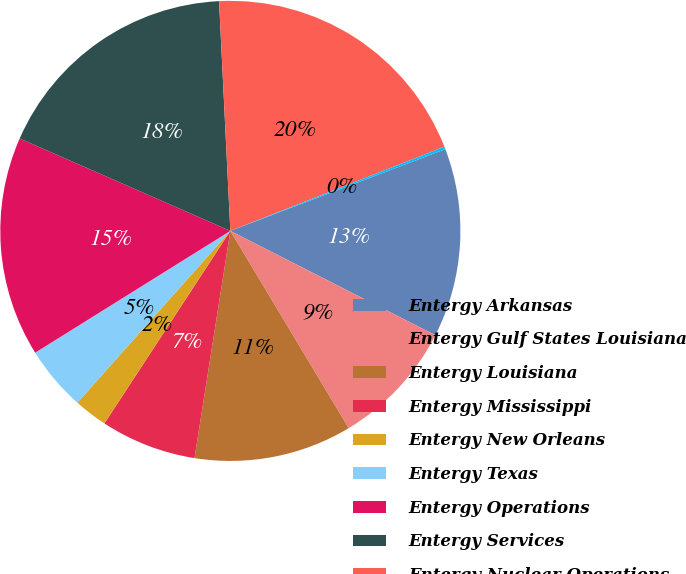Convert chart. <chart><loc_0><loc_0><loc_500><loc_500><pie_chart><fcel>Entergy Arkansas<fcel>Entergy Gulf States Louisiana<fcel>Entergy Louisiana<fcel>Entergy Mississippi<fcel>Entergy New Orleans<fcel>Entergy Texas<fcel>Entergy Operations<fcel>Entergy Services<fcel>Entergy Nuclear Operations<fcel>Other subsidiaries<nl><fcel>13.27%<fcel>8.91%<fcel>11.09%<fcel>6.73%<fcel>2.36%<fcel>4.54%<fcel>15.46%<fcel>17.64%<fcel>19.82%<fcel>0.18%<nl></chart> 